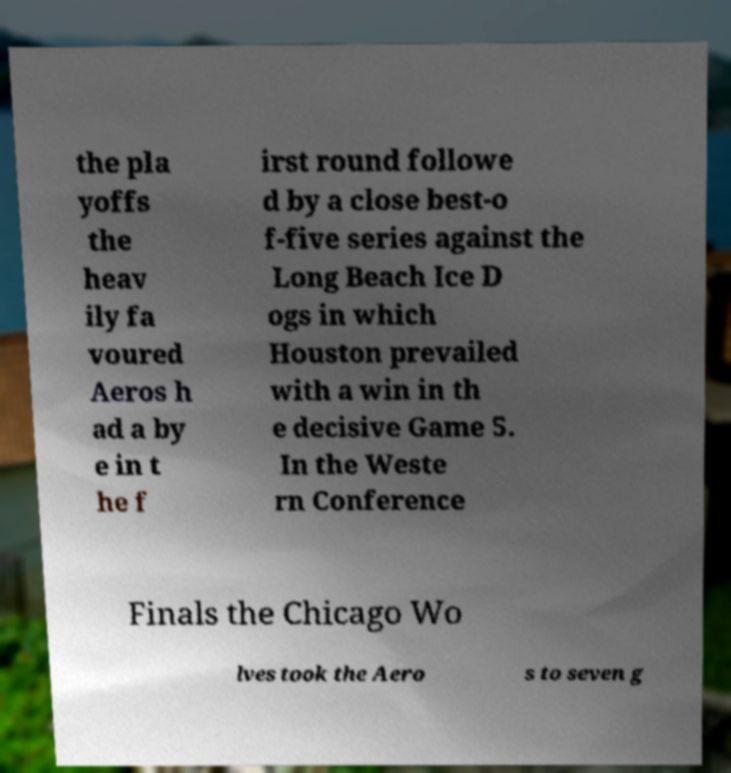There's text embedded in this image that I need extracted. Can you transcribe it verbatim? the pla yoffs the heav ily fa voured Aeros h ad a by e in t he f irst round followe d by a close best-o f-five series against the Long Beach Ice D ogs in which Houston prevailed with a win in th e decisive Game 5. In the Weste rn Conference Finals the Chicago Wo lves took the Aero s to seven g 